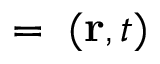Convert formula to latex. <formula><loc_0><loc_0><loc_500><loc_500>{ \xi } = { \xi } ( { r } , t )</formula> 